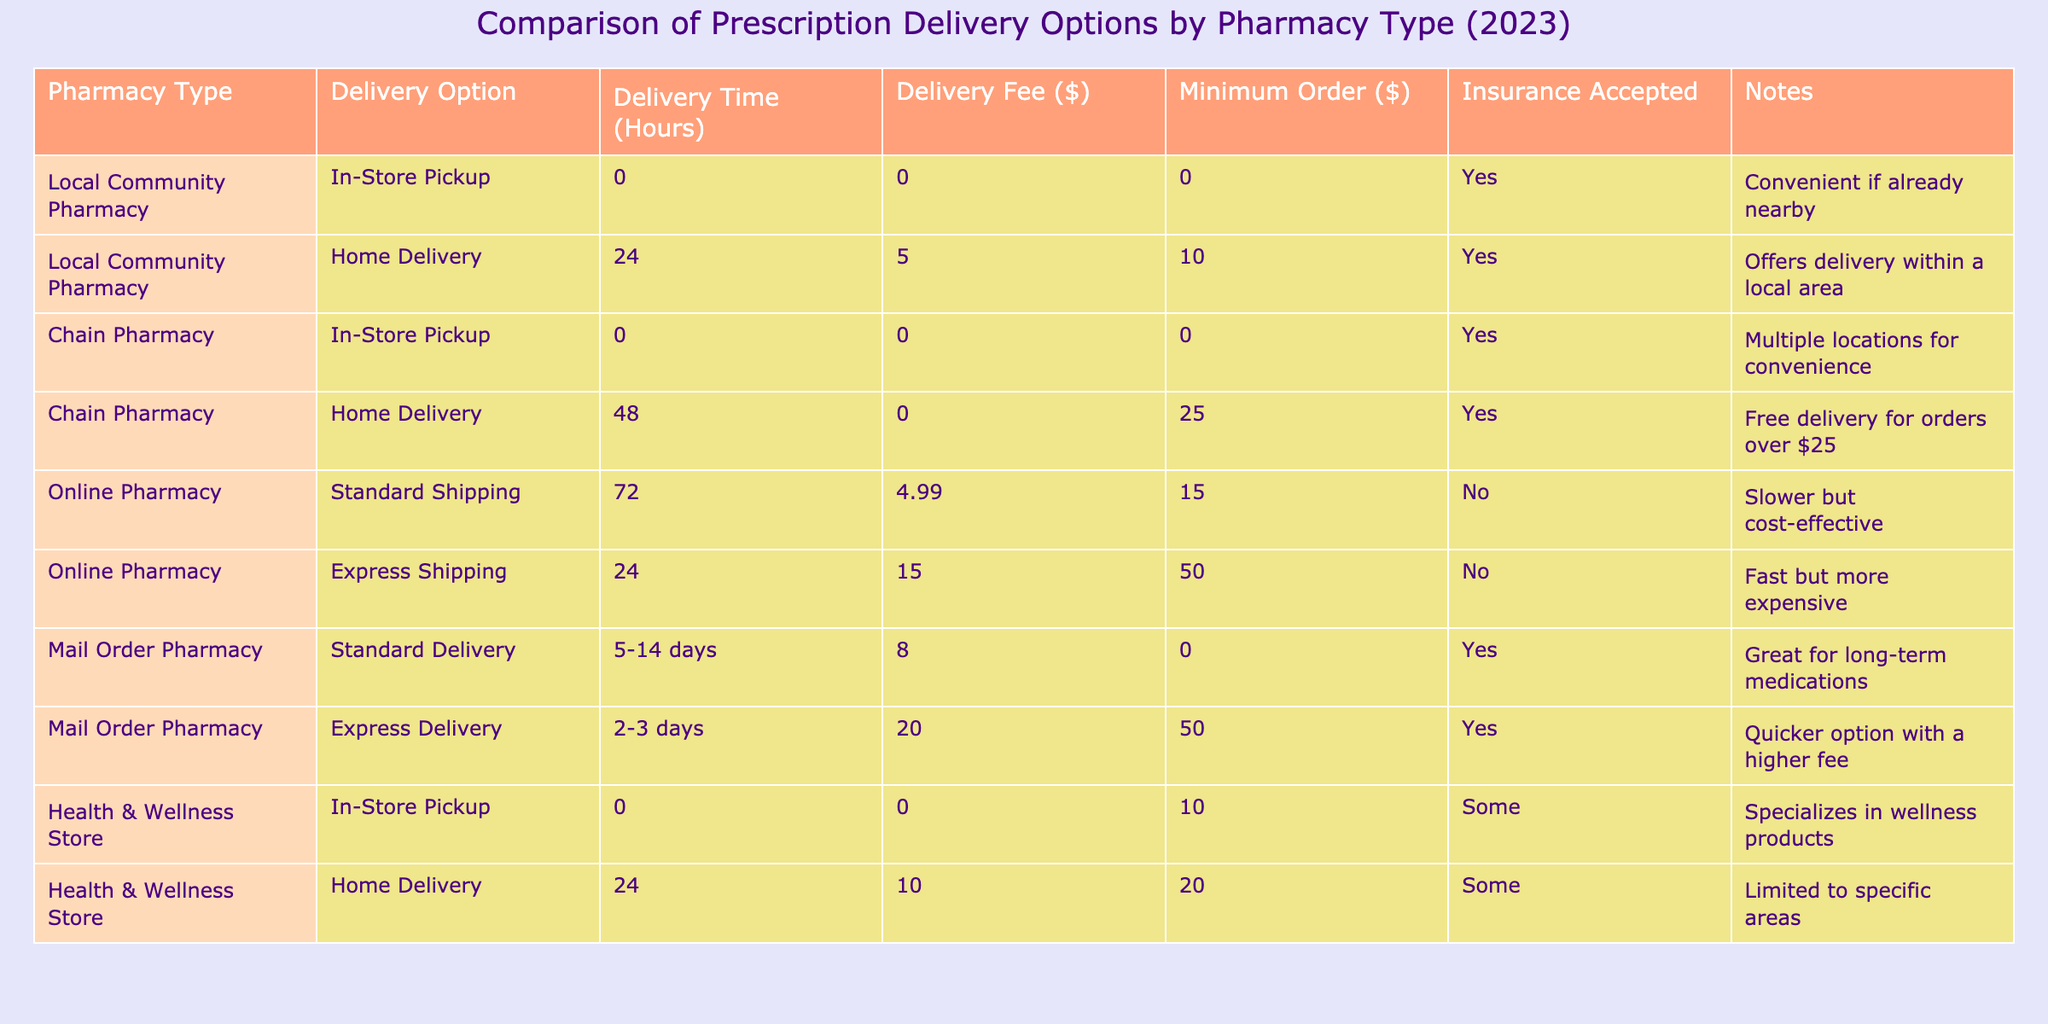What is the delivery fee for home delivery from a local community pharmacy? The delivery fee for home delivery from a local community pharmacy is listed as $5 in the table.
Answer: $5 How long does it take for express shipping from an online pharmacy? According to the table, express shipping from an online pharmacy takes 24 hours.
Answer: 24 hours Which pharmacy type accepts insurance for all their delivery options? The local community pharmacy, chain pharmacy, and mail order pharmacy all accept insurance for their delivery options.
Answer: Local community pharmacy, chain pharmacy, and mail order pharmacy What is the minimum order amount for express delivery from a mail order pharmacy? The minimum order amount for express delivery from a mail order pharmacy is $50, as stated in the table.
Answer: $50 Are any of the pharmacy delivery options free of charge? Yes, the chain pharmacy offers free home delivery for orders over $25, and both in-store pickup options have no delivery fee.
Answer: Yes Which delivery option takes the longest time from the online pharmacy? The standard shipping option from the online pharmacy takes the longest time at 72 hours.
Answer: 72 hours How many pharmacy types offer home delivery? From the table, there are four pharmacy types that offer home delivery: local community pharmacy, chain pharmacy, online pharmacy, and health & wellness store.
Answer: Four pharmacy types What is the difference in delivery time between standard delivery and express delivery for the mail order pharmacy? Standard delivery takes 5-14 days while express delivery takes 2-3 days. The difference ranges greatly, as standard delivery could take up to 14 days longer than express delivery.
Answer: Up to 14 days Is there a pharmacy type that doesn't accept insurance for any of its delivery options? Yes, the online pharmacy does not accept insurance for any of its delivery options.
Answer: Yes Which delivery option has the highest delivery fee? The delivery option with the highest fee is the express delivery from a mail order pharmacy, which costs $20.
Answer: $20 